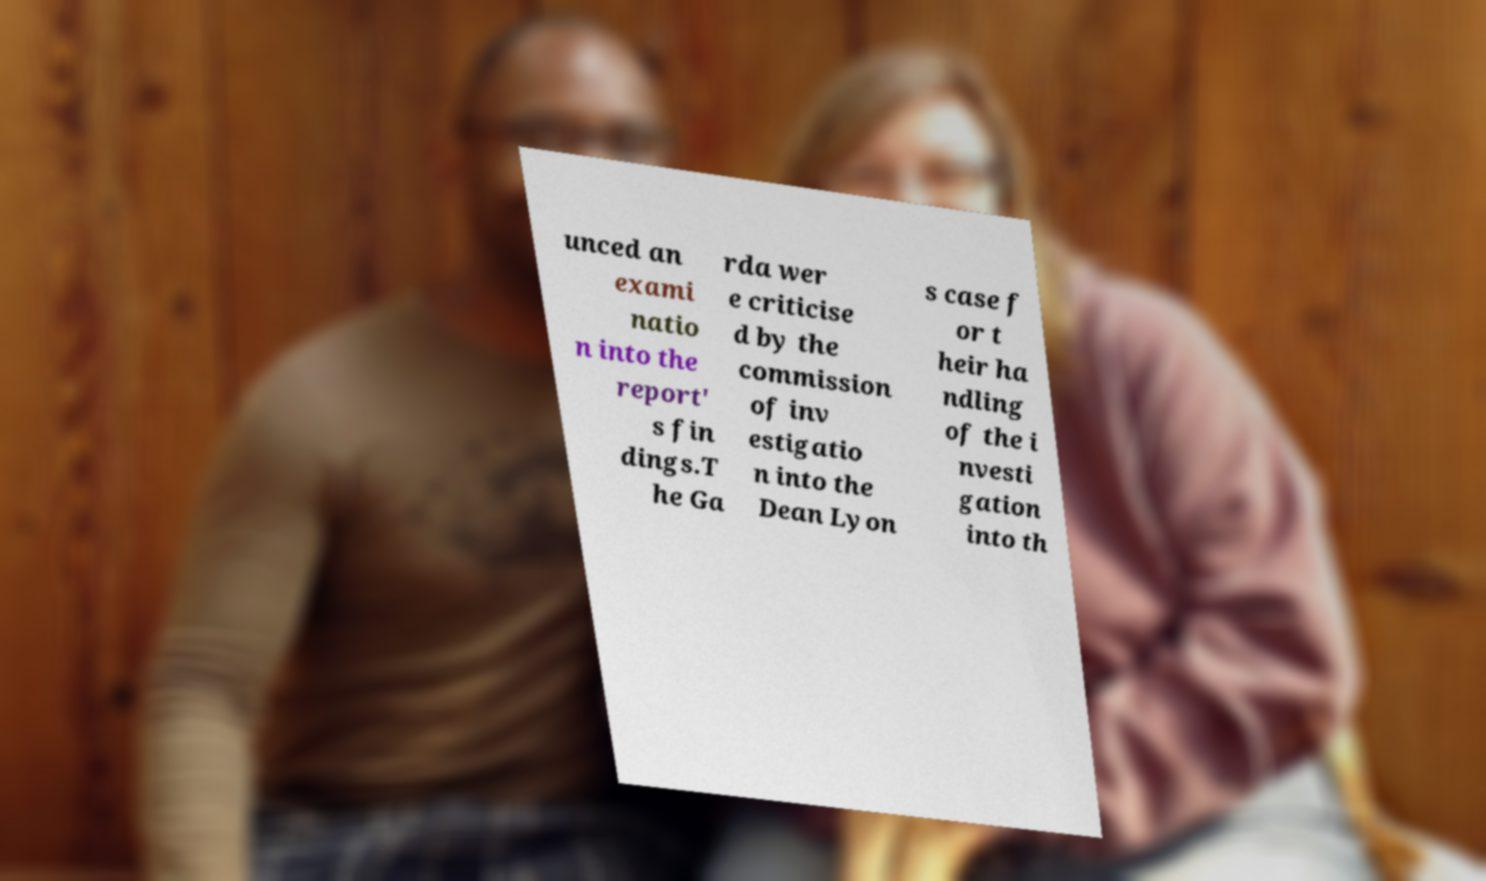Could you assist in decoding the text presented in this image and type it out clearly? unced an exami natio n into the report' s fin dings.T he Ga rda wer e criticise d by the commission of inv estigatio n into the Dean Lyon s case f or t heir ha ndling of the i nvesti gation into th 